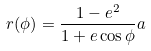<formula> <loc_0><loc_0><loc_500><loc_500>r ( \phi ) = \frac { 1 - e ^ { 2 } } { 1 + e \cos \phi } a \,</formula> 